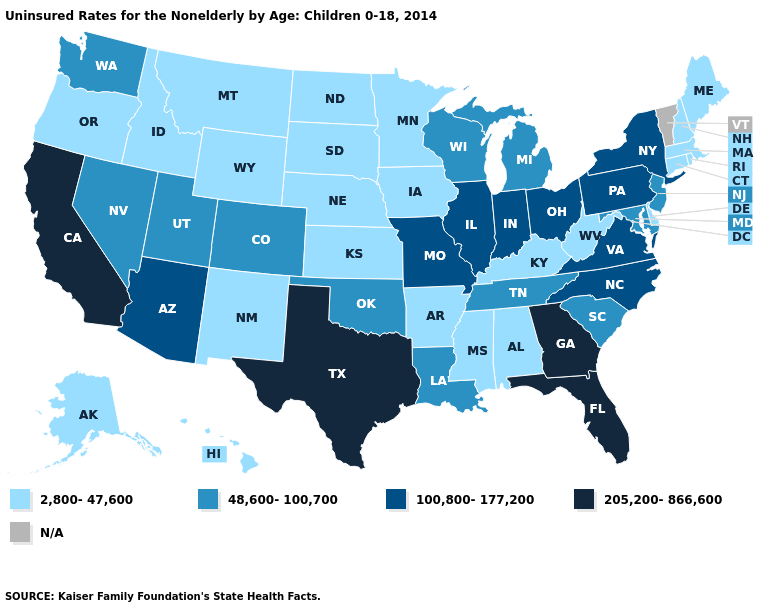Name the states that have a value in the range 48,600-100,700?
Keep it brief. Colorado, Louisiana, Maryland, Michigan, Nevada, New Jersey, Oklahoma, South Carolina, Tennessee, Utah, Washington, Wisconsin. What is the value of California?
Concise answer only. 205,200-866,600. Does Texas have the highest value in the USA?
Write a very short answer. Yes. Name the states that have a value in the range 48,600-100,700?
Be succinct. Colorado, Louisiana, Maryland, Michigan, Nevada, New Jersey, Oklahoma, South Carolina, Tennessee, Utah, Washington, Wisconsin. Which states have the highest value in the USA?
Quick response, please. California, Florida, Georgia, Texas. Name the states that have a value in the range 100,800-177,200?
Answer briefly. Arizona, Illinois, Indiana, Missouri, New York, North Carolina, Ohio, Pennsylvania, Virginia. Name the states that have a value in the range 48,600-100,700?
Short answer required. Colorado, Louisiana, Maryland, Michigan, Nevada, New Jersey, Oklahoma, South Carolina, Tennessee, Utah, Washington, Wisconsin. What is the highest value in the MidWest ?
Give a very brief answer. 100,800-177,200. Does the first symbol in the legend represent the smallest category?
Keep it brief. Yes. What is the value of Florida?
Keep it brief. 205,200-866,600. What is the value of Minnesota?
Write a very short answer. 2,800-47,600. What is the lowest value in states that border New Jersey?
Give a very brief answer. 2,800-47,600. Which states hav the highest value in the West?
Give a very brief answer. California. Does New Mexico have the lowest value in the USA?
Concise answer only. Yes. 